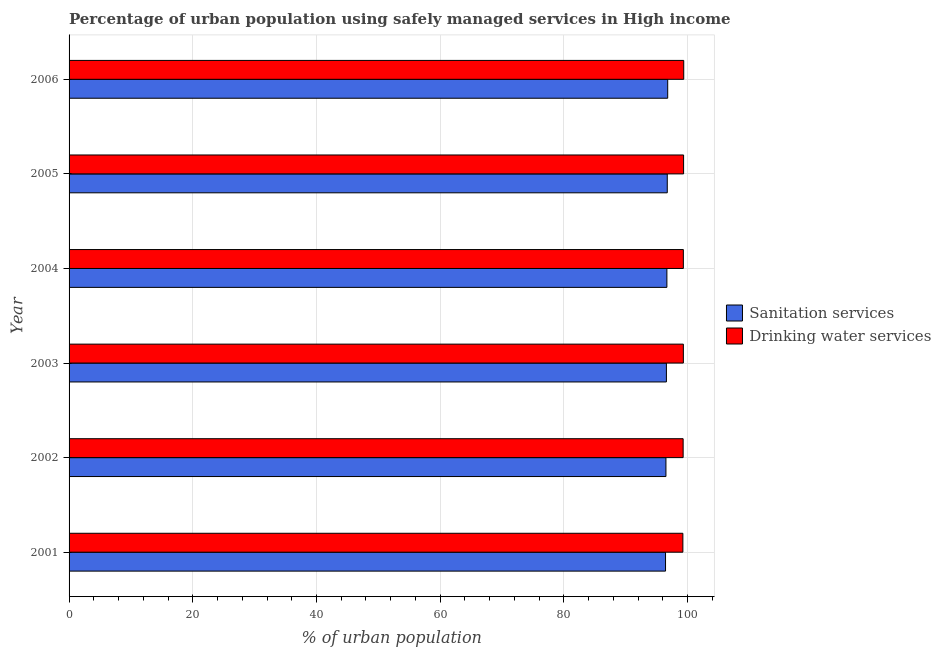How many different coloured bars are there?
Offer a terse response. 2. How many groups of bars are there?
Make the answer very short. 6. Are the number of bars per tick equal to the number of legend labels?
Give a very brief answer. Yes. What is the label of the 3rd group of bars from the top?
Offer a very short reply. 2004. What is the percentage of urban population who used sanitation services in 2006?
Make the answer very short. 96.78. Across all years, what is the maximum percentage of urban population who used drinking water services?
Provide a short and direct response. 99.37. Across all years, what is the minimum percentage of urban population who used drinking water services?
Keep it short and to the point. 99.23. What is the total percentage of urban population who used sanitation services in the graph?
Your response must be concise. 579.62. What is the difference between the percentage of urban population who used sanitation services in 2002 and that in 2004?
Your answer should be very brief. -0.15. What is the difference between the percentage of urban population who used sanitation services in 2005 and the percentage of urban population who used drinking water services in 2003?
Provide a succinct answer. -2.6. What is the average percentage of urban population who used sanitation services per year?
Your answer should be compact. 96.6. In the year 2005, what is the difference between the percentage of urban population who used sanitation services and percentage of urban population who used drinking water services?
Offer a terse response. -2.64. In how many years, is the percentage of urban population who used drinking water services greater than 8 %?
Make the answer very short. 6. Is the percentage of urban population who used sanitation services in 2001 less than that in 2005?
Your answer should be very brief. Yes. Is the difference between the percentage of urban population who used drinking water services in 2001 and 2002 greater than the difference between the percentage of urban population who used sanitation services in 2001 and 2002?
Offer a very short reply. Yes. What is the difference between the highest and the second highest percentage of urban population who used drinking water services?
Ensure brevity in your answer.  0.02. What is the difference between the highest and the lowest percentage of urban population who used drinking water services?
Provide a short and direct response. 0.14. What does the 2nd bar from the top in 2002 represents?
Your answer should be very brief. Sanitation services. What does the 2nd bar from the bottom in 2006 represents?
Give a very brief answer. Drinking water services. Are all the bars in the graph horizontal?
Provide a short and direct response. Yes. How many years are there in the graph?
Your answer should be very brief. 6. What is the difference between two consecutive major ticks on the X-axis?
Ensure brevity in your answer.  20. Does the graph contain any zero values?
Provide a succinct answer. No. Where does the legend appear in the graph?
Your response must be concise. Center right. How many legend labels are there?
Provide a short and direct response. 2. How are the legend labels stacked?
Your response must be concise. Vertical. What is the title of the graph?
Offer a terse response. Percentage of urban population using safely managed services in High income. Does "Food and tobacco" appear as one of the legend labels in the graph?
Provide a succinct answer. No. What is the label or title of the X-axis?
Your answer should be very brief. % of urban population. What is the label or title of the Y-axis?
Provide a short and direct response. Year. What is the % of urban population in Sanitation services in 2001?
Provide a succinct answer. 96.43. What is the % of urban population of Drinking water services in 2001?
Your answer should be compact. 99.23. What is the % of urban population in Sanitation services in 2002?
Your answer should be compact. 96.49. What is the % of urban population of Drinking water services in 2002?
Give a very brief answer. 99.27. What is the % of urban population of Sanitation services in 2003?
Your answer should be very brief. 96.57. What is the % of urban population in Drinking water services in 2003?
Offer a very short reply. 99.31. What is the % of urban population of Sanitation services in 2004?
Provide a succinct answer. 96.65. What is the % of urban population in Drinking water services in 2004?
Offer a terse response. 99.31. What is the % of urban population of Sanitation services in 2005?
Ensure brevity in your answer.  96.71. What is the % of urban population of Drinking water services in 2005?
Ensure brevity in your answer.  99.35. What is the % of urban population of Sanitation services in 2006?
Give a very brief answer. 96.78. What is the % of urban population in Drinking water services in 2006?
Offer a very short reply. 99.37. Across all years, what is the maximum % of urban population of Sanitation services?
Your response must be concise. 96.78. Across all years, what is the maximum % of urban population in Drinking water services?
Offer a terse response. 99.37. Across all years, what is the minimum % of urban population of Sanitation services?
Provide a succinct answer. 96.43. Across all years, what is the minimum % of urban population of Drinking water services?
Give a very brief answer. 99.23. What is the total % of urban population in Sanitation services in the graph?
Ensure brevity in your answer.  579.62. What is the total % of urban population in Drinking water services in the graph?
Make the answer very short. 595.83. What is the difference between the % of urban population in Sanitation services in 2001 and that in 2002?
Offer a terse response. -0.07. What is the difference between the % of urban population in Drinking water services in 2001 and that in 2002?
Make the answer very short. -0.04. What is the difference between the % of urban population of Sanitation services in 2001 and that in 2003?
Provide a succinct answer. -0.14. What is the difference between the % of urban population of Drinking water services in 2001 and that in 2003?
Give a very brief answer. -0.08. What is the difference between the % of urban population of Sanitation services in 2001 and that in 2004?
Provide a short and direct response. -0.22. What is the difference between the % of urban population in Drinking water services in 2001 and that in 2004?
Your answer should be very brief. -0.08. What is the difference between the % of urban population in Sanitation services in 2001 and that in 2005?
Make the answer very short. -0.28. What is the difference between the % of urban population of Drinking water services in 2001 and that in 2005?
Offer a very short reply. -0.11. What is the difference between the % of urban population of Sanitation services in 2001 and that in 2006?
Your answer should be very brief. -0.35. What is the difference between the % of urban population of Drinking water services in 2001 and that in 2006?
Offer a very short reply. -0.14. What is the difference between the % of urban population in Sanitation services in 2002 and that in 2003?
Give a very brief answer. -0.07. What is the difference between the % of urban population of Drinking water services in 2002 and that in 2003?
Your answer should be very brief. -0.04. What is the difference between the % of urban population of Sanitation services in 2002 and that in 2004?
Your answer should be very brief. -0.15. What is the difference between the % of urban population in Drinking water services in 2002 and that in 2004?
Offer a terse response. -0.03. What is the difference between the % of urban population in Sanitation services in 2002 and that in 2005?
Your answer should be very brief. -0.21. What is the difference between the % of urban population of Drinking water services in 2002 and that in 2005?
Ensure brevity in your answer.  -0.07. What is the difference between the % of urban population in Sanitation services in 2002 and that in 2006?
Provide a short and direct response. -0.28. What is the difference between the % of urban population in Drinking water services in 2002 and that in 2006?
Keep it short and to the point. -0.09. What is the difference between the % of urban population of Sanitation services in 2003 and that in 2004?
Your answer should be very brief. -0.08. What is the difference between the % of urban population in Drinking water services in 2003 and that in 2004?
Your answer should be compact. 0. What is the difference between the % of urban population in Sanitation services in 2003 and that in 2005?
Provide a short and direct response. -0.14. What is the difference between the % of urban population in Drinking water services in 2003 and that in 2005?
Ensure brevity in your answer.  -0.04. What is the difference between the % of urban population of Sanitation services in 2003 and that in 2006?
Ensure brevity in your answer.  -0.21. What is the difference between the % of urban population of Drinking water services in 2003 and that in 2006?
Your answer should be very brief. -0.06. What is the difference between the % of urban population of Sanitation services in 2004 and that in 2005?
Offer a terse response. -0.06. What is the difference between the % of urban population in Drinking water services in 2004 and that in 2005?
Your answer should be very brief. -0.04. What is the difference between the % of urban population of Sanitation services in 2004 and that in 2006?
Your answer should be compact. -0.13. What is the difference between the % of urban population of Drinking water services in 2004 and that in 2006?
Your answer should be compact. -0.06. What is the difference between the % of urban population of Sanitation services in 2005 and that in 2006?
Provide a succinct answer. -0.07. What is the difference between the % of urban population of Drinking water services in 2005 and that in 2006?
Provide a short and direct response. -0.02. What is the difference between the % of urban population in Sanitation services in 2001 and the % of urban population in Drinking water services in 2002?
Provide a succinct answer. -2.85. What is the difference between the % of urban population of Sanitation services in 2001 and the % of urban population of Drinking water services in 2003?
Offer a terse response. -2.88. What is the difference between the % of urban population in Sanitation services in 2001 and the % of urban population in Drinking water services in 2004?
Provide a short and direct response. -2.88. What is the difference between the % of urban population in Sanitation services in 2001 and the % of urban population in Drinking water services in 2005?
Provide a succinct answer. -2.92. What is the difference between the % of urban population of Sanitation services in 2001 and the % of urban population of Drinking water services in 2006?
Give a very brief answer. -2.94. What is the difference between the % of urban population of Sanitation services in 2002 and the % of urban population of Drinking water services in 2003?
Offer a very short reply. -2.82. What is the difference between the % of urban population of Sanitation services in 2002 and the % of urban population of Drinking water services in 2004?
Your answer should be very brief. -2.82. What is the difference between the % of urban population of Sanitation services in 2002 and the % of urban population of Drinking water services in 2005?
Offer a very short reply. -2.85. What is the difference between the % of urban population of Sanitation services in 2002 and the % of urban population of Drinking water services in 2006?
Offer a terse response. -2.88. What is the difference between the % of urban population in Sanitation services in 2003 and the % of urban population in Drinking water services in 2004?
Offer a very short reply. -2.74. What is the difference between the % of urban population of Sanitation services in 2003 and the % of urban population of Drinking water services in 2005?
Make the answer very short. -2.78. What is the difference between the % of urban population in Sanitation services in 2003 and the % of urban population in Drinking water services in 2006?
Keep it short and to the point. -2.8. What is the difference between the % of urban population in Sanitation services in 2004 and the % of urban population in Drinking water services in 2005?
Ensure brevity in your answer.  -2.7. What is the difference between the % of urban population in Sanitation services in 2004 and the % of urban population in Drinking water services in 2006?
Provide a short and direct response. -2.72. What is the difference between the % of urban population of Sanitation services in 2005 and the % of urban population of Drinking water services in 2006?
Offer a very short reply. -2.66. What is the average % of urban population of Sanitation services per year?
Your answer should be compact. 96.6. What is the average % of urban population of Drinking water services per year?
Provide a short and direct response. 99.31. In the year 2001, what is the difference between the % of urban population in Sanitation services and % of urban population in Drinking water services?
Give a very brief answer. -2.8. In the year 2002, what is the difference between the % of urban population in Sanitation services and % of urban population in Drinking water services?
Your answer should be compact. -2.78. In the year 2003, what is the difference between the % of urban population of Sanitation services and % of urban population of Drinking water services?
Your answer should be compact. -2.74. In the year 2004, what is the difference between the % of urban population in Sanitation services and % of urban population in Drinking water services?
Make the answer very short. -2.66. In the year 2005, what is the difference between the % of urban population in Sanitation services and % of urban population in Drinking water services?
Ensure brevity in your answer.  -2.64. In the year 2006, what is the difference between the % of urban population in Sanitation services and % of urban population in Drinking water services?
Keep it short and to the point. -2.59. What is the ratio of the % of urban population of Drinking water services in 2001 to that in 2002?
Ensure brevity in your answer.  1. What is the ratio of the % of urban population in Sanitation services in 2001 to that in 2003?
Offer a terse response. 1. What is the ratio of the % of urban population of Drinking water services in 2001 to that in 2003?
Give a very brief answer. 1. What is the ratio of the % of urban population of Sanitation services in 2001 to that in 2004?
Your answer should be very brief. 1. What is the ratio of the % of urban population in Sanitation services in 2001 to that in 2005?
Keep it short and to the point. 1. What is the ratio of the % of urban population in Sanitation services in 2001 to that in 2006?
Offer a very short reply. 1. What is the ratio of the % of urban population of Drinking water services in 2001 to that in 2006?
Give a very brief answer. 1. What is the ratio of the % of urban population in Drinking water services in 2002 to that in 2003?
Your answer should be compact. 1. What is the ratio of the % of urban population of Sanitation services in 2002 to that in 2004?
Your response must be concise. 1. What is the ratio of the % of urban population of Sanitation services in 2002 to that in 2005?
Provide a short and direct response. 1. What is the ratio of the % of urban population of Drinking water services in 2002 to that in 2005?
Give a very brief answer. 1. What is the ratio of the % of urban population of Drinking water services in 2002 to that in 2006?
Offer a very short reply. 1. What is the ratio of the % of urban population in Sanitation services in 2003 to that in 2004?
Keep it short and to the point. 1. What is the ratio of the % of urban population of Drinking water services in 2003 to that in 2005?
Your answer should be very brief. 1. What is the ratio of the % of urban population of Drinking water services in 2003 to that in 2006?
Provide a short and direct response. 1. What is the ratio of the % of urban population in Drinking water services in 2004 to that in 2006?
Provide a short and direct response. 1. What is the ratio of the % of urban population of Sanitation services in 2005 to that in 2006?
Offer a terse response. 1. What is the difference between the highest and the second highest % of urban population of Sanitation services?
Your answer should be very brief. 0.07. What is the difference between the highest and the second highest % of urban population of Drinking water services?
Your response must be concise. 0.02. What is the difference between the highest and the lowest % of urban population in Drinking water services?
Make the answer very short. 0.14. 